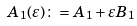<formula> <loc_0><loc_0><loc_500><loc_500>A _ { 1 } ( \varepsilon ) \colon = A _ { 1 } + \varepsilon B _ { 1 }</formula> 